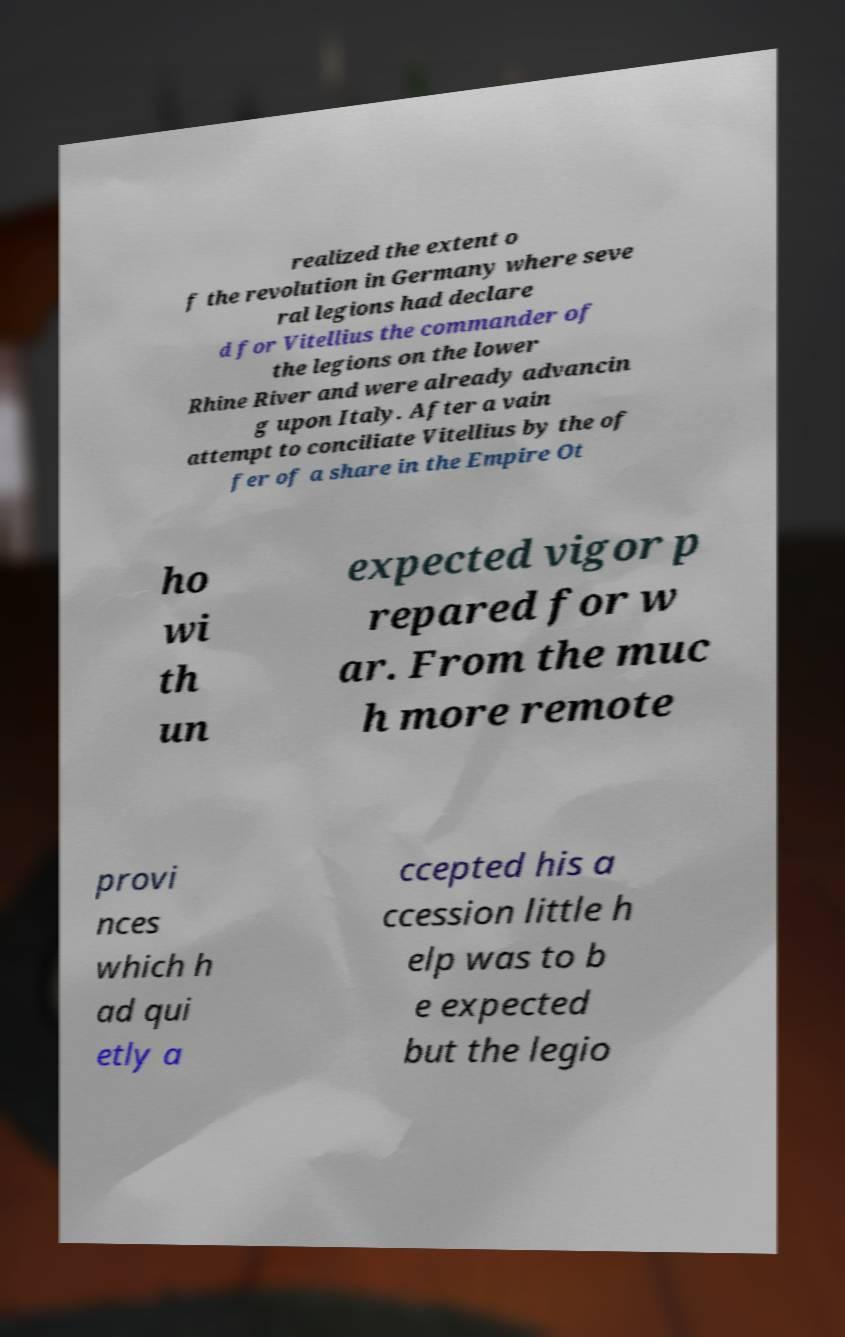Can you read and provide the text displayed in the image?This photo seems to have some interesting text. Can you extract and type it out for me? realized the extent o f the revolution in Germany where seve ral legions had declare d for Vitellius the commander of the legions on the lower Rhine River and were already advancin g upon Italy. After a vain attempt to conciliate Vitellius by the of fer of a share in the Empire Ot ho wi th un expected vigor p repared for w ar. From the muc h more remote provi nces which h ad qui etly a ccepted his a ccession little h elp was to b e expected but the legio 